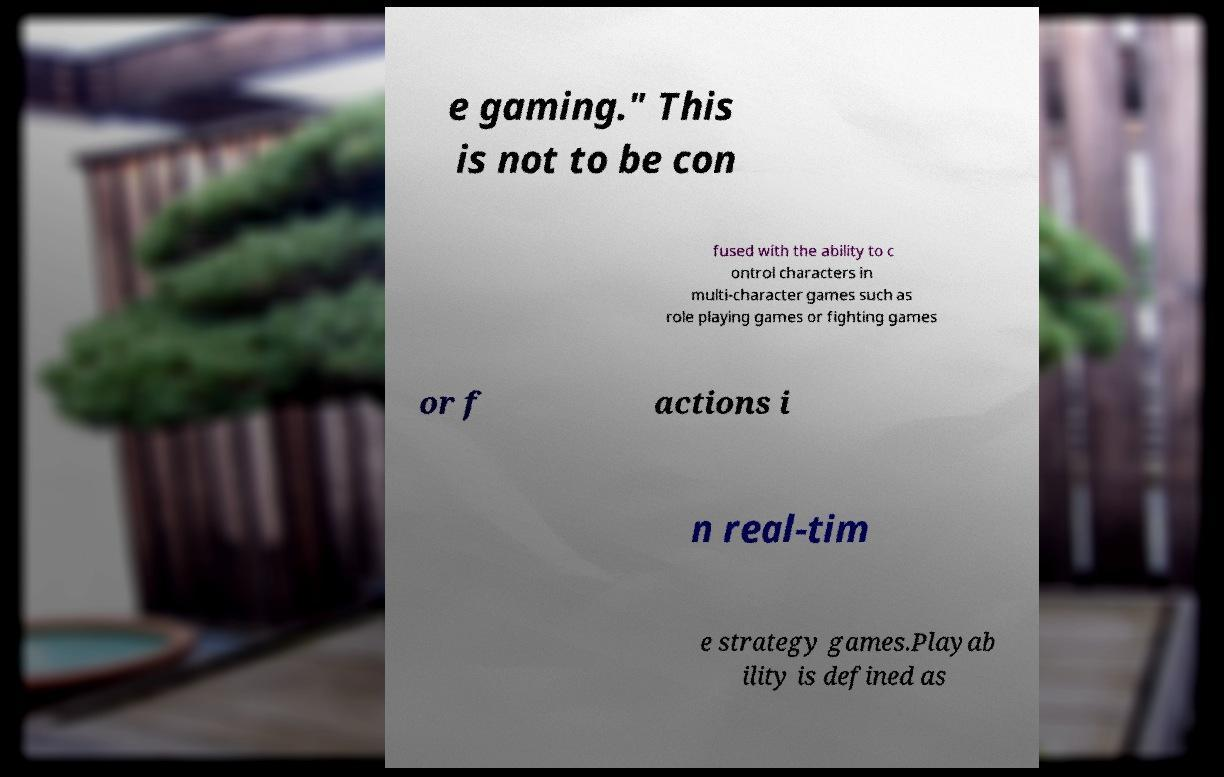I need the written content from this picture converted into text. Can you do that? e gaming." This is not to be con fused with the ability to c ontrol characters in multi-character games such as role playing games or fighting games or f actions i n real-tim e strategy games.Playab ility is defined as 